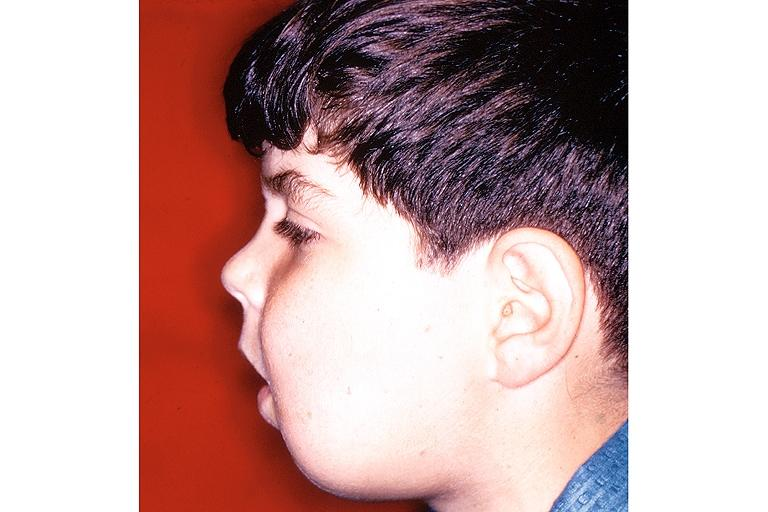what is present?
Answer the question using a single word or phrase. Oral 